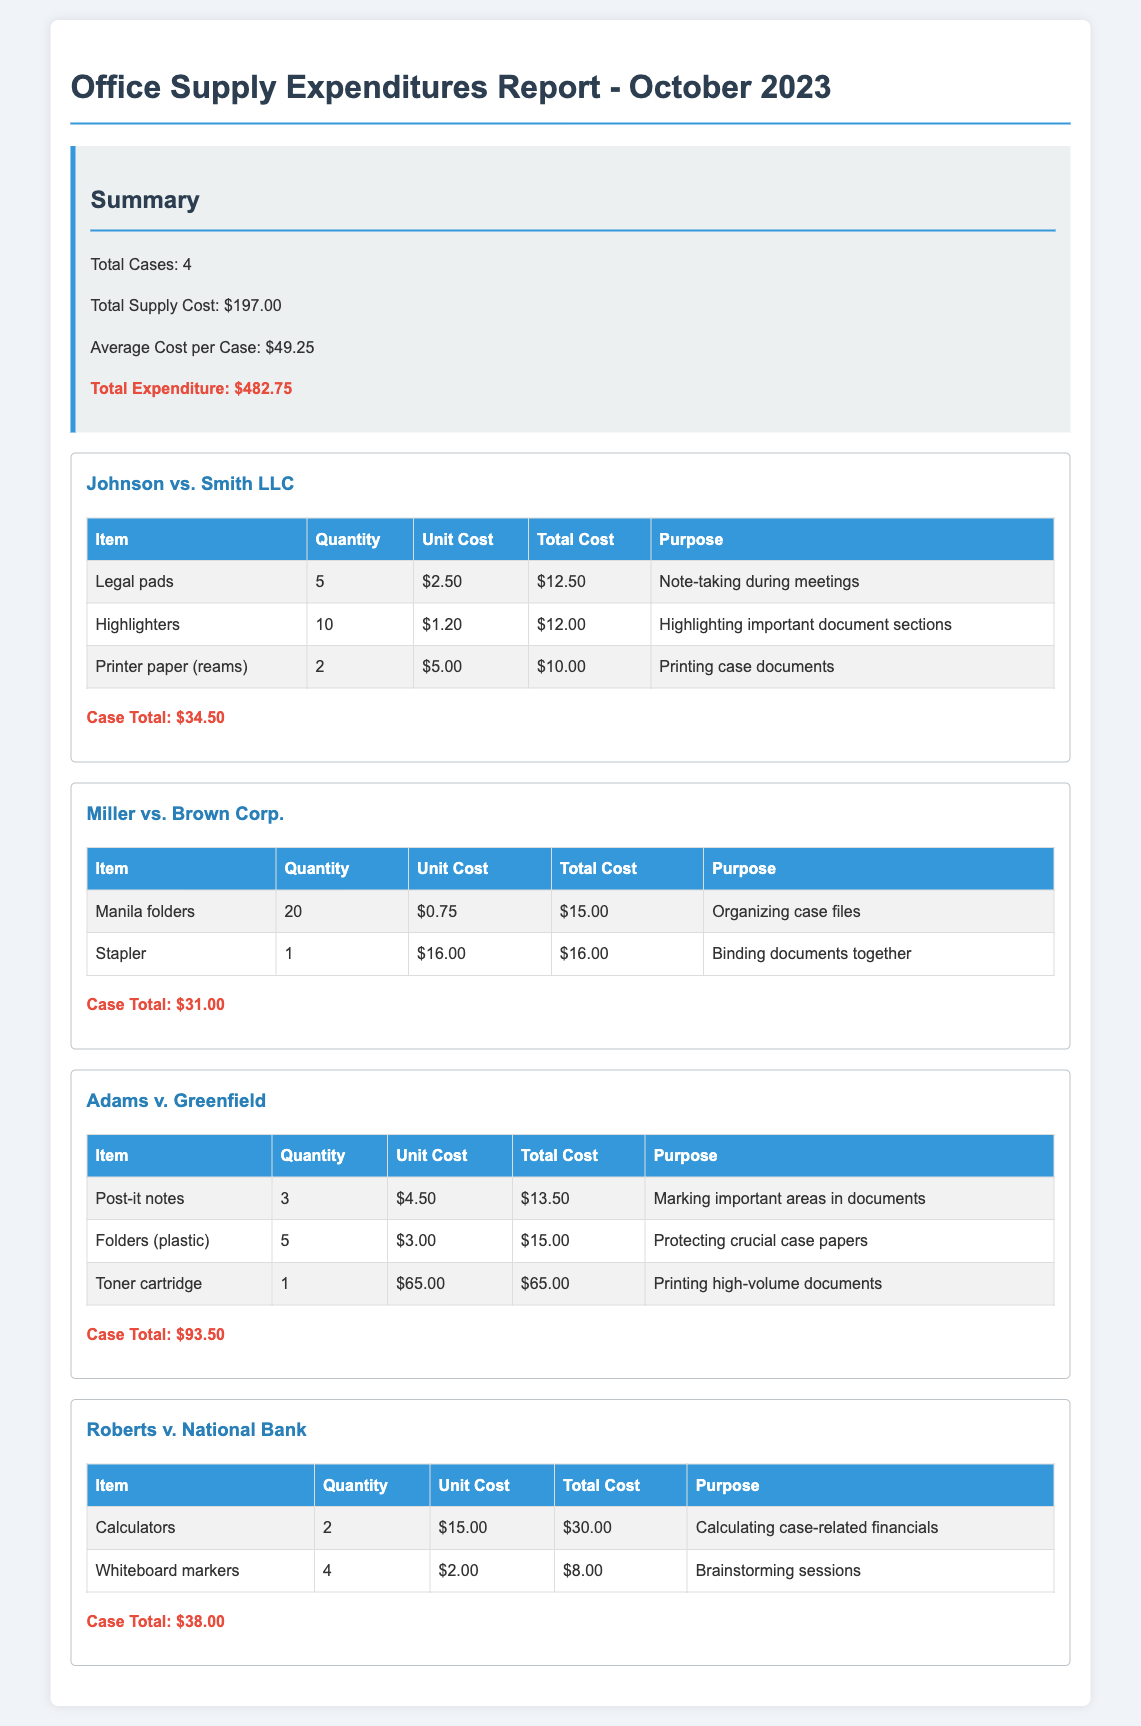What is the total number of cases? The total number of cases is provided in the summary section of the document.
Answer: 4 What is the total supply cost? The total supply cost is detailed in the summary section as the sum of all individual case expenditures.
Answer: $197.00 How much did the Johnson vs. Smith LLC case spend? The total expenditure for the Johnson vs. Smith LLC case is noted after the case details.
Answer: $34.50 What item was purchased for organizing case files? The document lists the items and their purposes for each case, the item for organizing case files is mentioned.
Answer: Manila folders Which case had the highest total cost? The total costs for each case can be compared to determine which is highest, and the document specifies the amounts.
Answer: Adams v. Greenfield What was the purpose of the toner cartridge purchase? The purpose of each item purchased is stated in the document for clarity on their use in the cases.
Answer: Printing high-volume documents What is the total expenditure? The total expenditure consists of the summed costs of all cases and is captured in the summary section.
Answer: $482.75 How many highlighters were purchased for the Johnson vs. Smith LLC case? The quantity of each item is listed in the table under Johnson vs. Smith LLC for easy retrieval.
Answer: 10 What is the average cost per case? The average cost per case is calculated and presented in the summary section of the report.
Answer: $49.25 